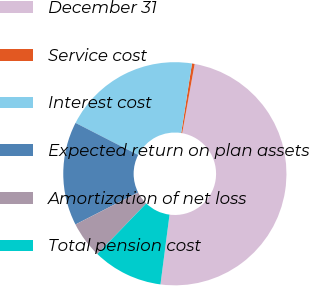Convert chart to OTSL. <chart><loc_0><loc_0><loc_500><loc_500><pie_chart><fcel>December 31<fcel>Service cost<fcel>Interest cost<fcel>Expected return on plan assets<fcel>Amortization of net loss<fcel>Total pension cost<nl><fcel>49.22%<fcel>0.39%<fcel>19.92%<fcel>15.04%<fcel>5.27%<fcel>10.16%<nl></chart> 